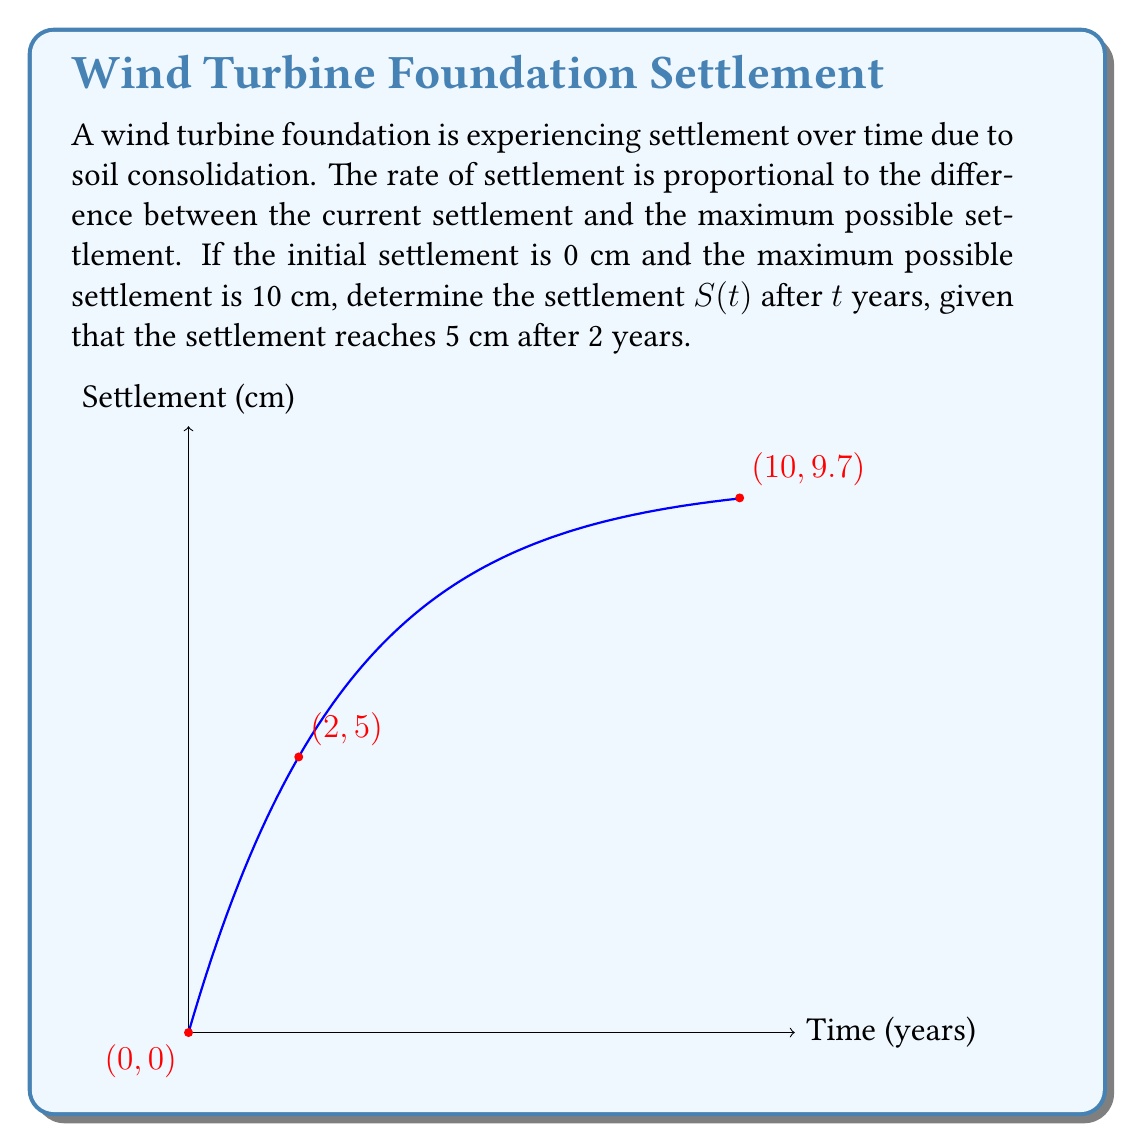Can you answer this question? Let's approach this step-by-step:

1) Let $S(t)$ be the settlement at time $t$. The rate of change of settlement is proportional to the difference between the maximum settlement and the current settlement:

   $$\frac{dS}{dt} = k(10 - S)$$

   where $k$ is the proportionality constant.

2) This is a first-order linear differential equation. Its general solution is:

   $$S(t) = 10 - Ce^{-kt}$$

   where $C$ is a constant of integration.

3) Using the initial condition $S(0) = 0$, we find:

   $$0 = 10 - C$$
   $$C = 10$$

4) So our particular solution is:

   $$S(t) = 10(1 - e^{-kt})$$

5) Now we use the condition that $S(2) = 5$:

   $$5 = 10(1 - e^{-2k})$$
   $$0.5 = 1 - e^{-2k}$$
   $$e^{-2k} = 0.5$$
   $$-2k = \ln(0.5)$$
   $$k = -\frac{1}{2}\ln(0.5) \approx 0.347$$

6) Therefore, our final solution is:

   $$S(t) = 10(1 - e^{-0.347t})$$

This equation gives the settlement $S$ in cm after $t$ years.
Answer: $S(t) = 10(1 - e^{-0.347t})$ cm 